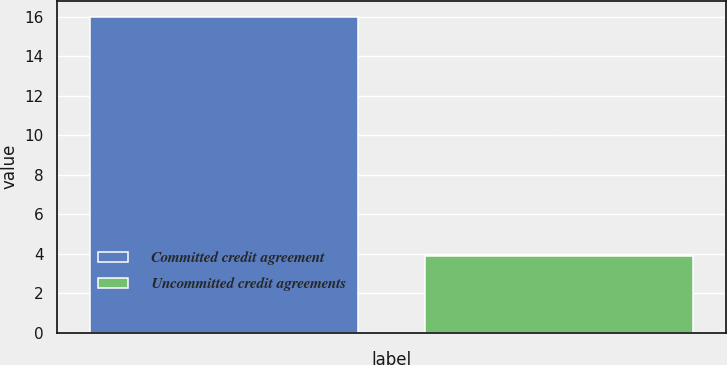Convert chart. <chart><loc_0><loc_0><loc_500><loc_500><bar_chart><fcel>Committed credit agreement<fcel>Uncommitted credit agreements<nl><fcel>16<fcel>3.9<nl></chart> 